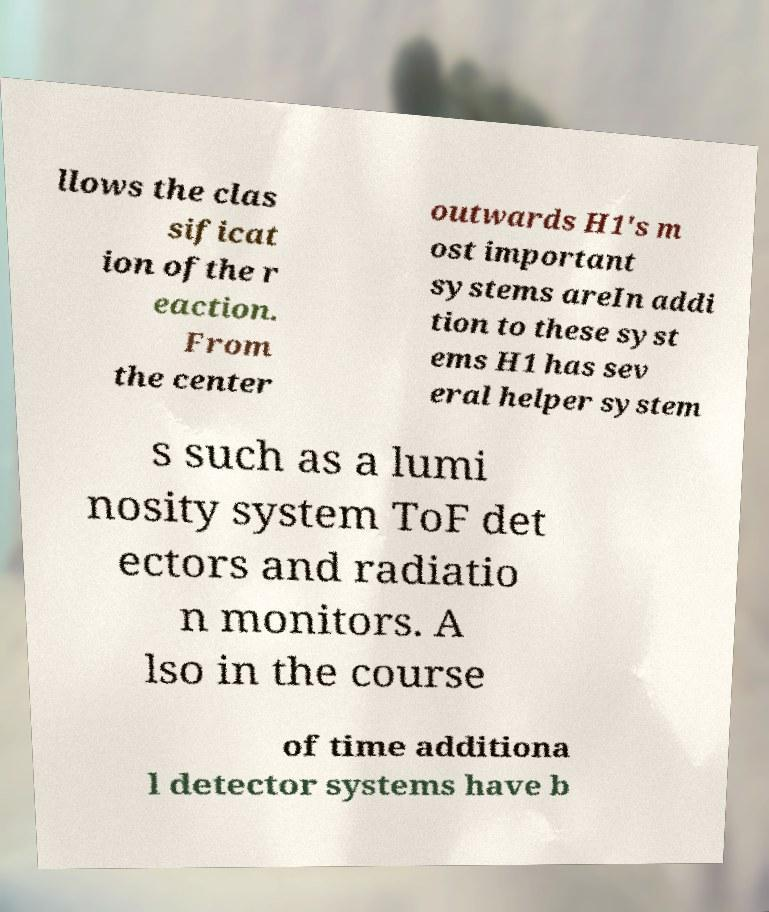Could you assist in decoding the text presented in this image and type it out clearly? llows the clas sificat ion ofthe r eaction. From the center outwards H1's m ost important systems areIn addi tion to these syst ems H1 has sev eral helper system s such as a lumi nosity system ToF det ectors and radiatio n monitors. A lso in the course of time additiona l detector systems have b 